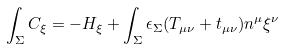Convert formula to latex. <formula><loc_0><loc_0><loc_500><loc_500>\int _ { \Sigma } C _ { \xi } = - H _ { \xi } + \int _ { \Sigma } \epsilon _ { \Sigma } ( T _ { \mu \nu } + t _ { \mu \nu } ) n ^ { \mu } \xi ^ { \nu }</formula> 